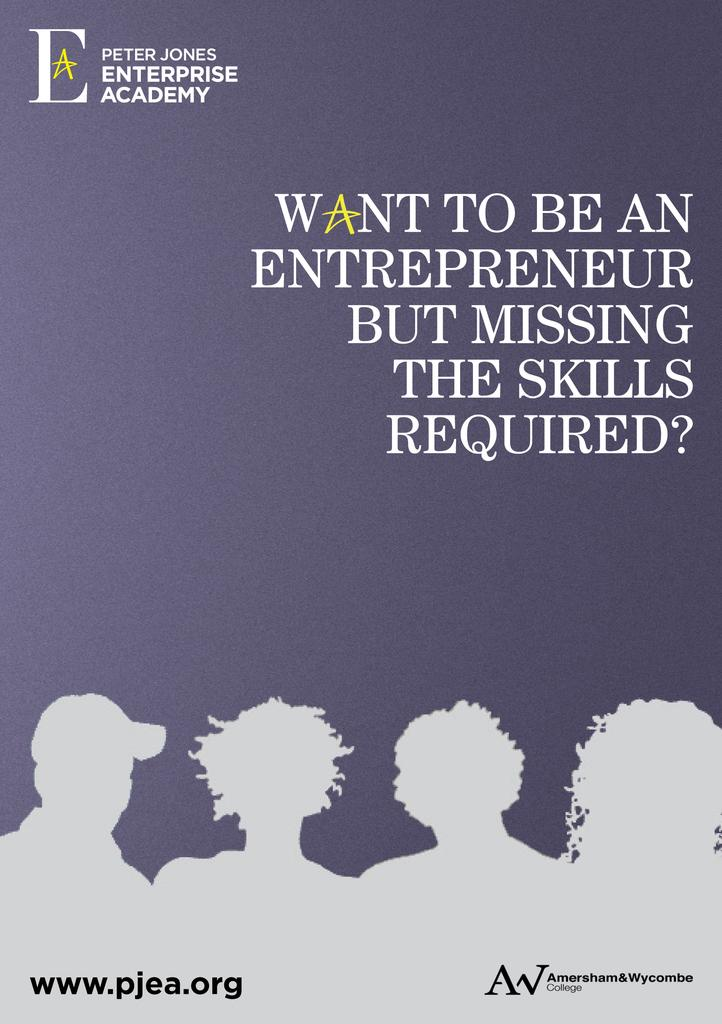<image>
Create a compact narrative representing the image presented. An advertisement for the Peter Jones Enterprise Academy for aspiring entrepreneurs. 